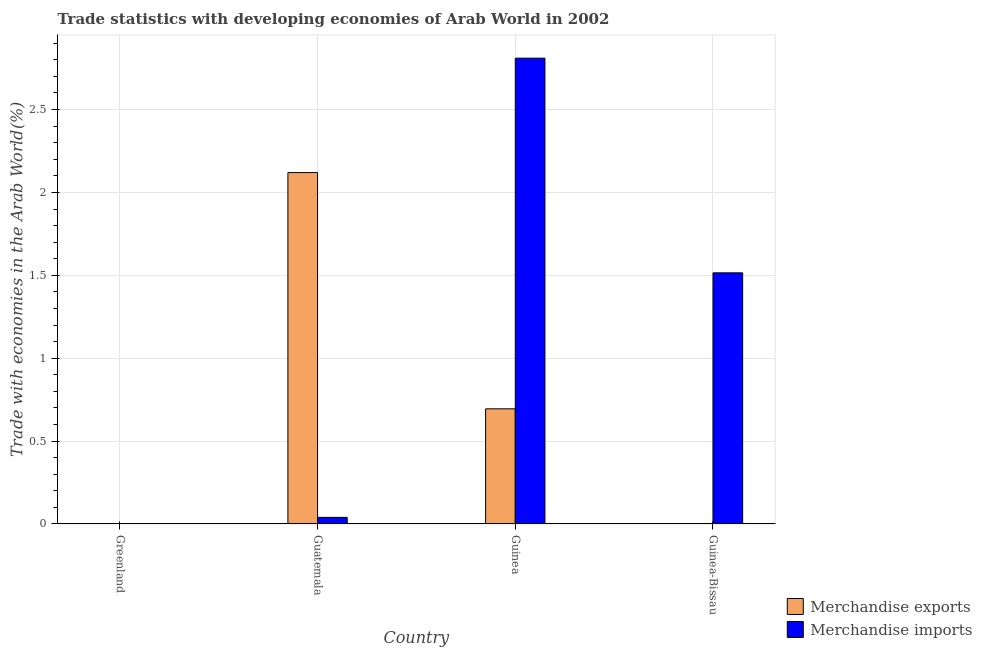How many groups of bars are there?
Offer a terse response. 4. Are the number of bars per tick equal to the number of legend labels?
Provide a short and direct response. Yes. What is the label of the 3rd group of bars from the left?
Provide a short and direct response. Guinea. What is the merchandise exports in Greenland?
Give a very brief answer. 0. Across all countries, what is the maximum merchandise exports?
Keep it short and to the point. 2.12. Across all countries, what is the minimum merchandise exports?
Provide a short and direct response. 0. In which country was the merchandise imports maximum?
Your answer should be very brief. Guinea. In which country was the merchandise exports minimum?
Your response must be concise. Greenland. What is the total merchandise exports in the graph?
Your response must be concise. 2.82. What is the difference between the merchandise imports in Guatemala and that in Guinea-Bissau?
Provide a succinct answer. -1.48. What is the difference between the merchandise exports in Greenland and the merchandise imports in Guinea?
Provide a short and direct response. -2.81. What is the average merchandise exports per country?
Provide a short and direct response. 0.7. What is the difference between the merchandise imports and merchandise exports in Guatemala?
Provide a short and direct response. -2.08. What is the ratio of the merchandise exports in Greenland to that in Guatemala?
Your answer should be compact. 8.268428974490069e-5. What is the difference between the highest and the second highest merchandise imports?
Make the answer very short. 1.29. What is the difference between the highest and the lowest merchandise imports?
Provide a succinct answer. 2.81. In how many countries, is the merchandise exports greater than the average merchandise exports taken over all countries?
Provide a short and direct response. 1. Is the sum of the merchandise imports in Greenland and Guinea-Bissau greater than the maximum merchandise exports across all countries?
Offer a very short reply. No. How many bars are there?
Your response must be concise. 8. Are all the bars in the graph horizontal?
Make the answer very short. No. How many countries are there in the graph?
Offer a terse response. 4. How many legend labels are there?
Your answer should be compact. 2. What is the title of the graph?
Offer a terse response. Trade statistics with developing economies of Arab World in 2002. What is the label or title of the Y-axis?
Your answer should be compact. Trade with economies in the Arab World(%). What is the Trade with economies in the Arab World(%) of Merchandise exports in Greenland?
Provide a short and direct response. 0. What is the Trade with economies in the Arab World(%) of Merchandise imports in Greenland?
Your answer should be very brief. 0. What is the Trade with economies in the Arab World(%) of Merchandise exports in Guatemala?
Provide a short and direct response. 2.12. What is the Trade with economies in the Arab World(%) of Merchandise imports in Guatemala?
Offer a terse response. 0.04. What is the Trade with economies in the Arab World(%) in Merchandise exports in Guinea?
Your response must be concise. 0.69. What is the Trade with economies in the Arab World(%) of Merchandise imports in Guinea?
Ensure brevity in your answer.  2.81. What is the Trade with economies in the Arab World(%) of Merchandise exports in Guinea-Bissau?
Your response must be concise. 0. What is the Trade with economies in the Arab World(%) in Merchandise imports in Guinea-Bissau?
Provide a short and direct response. 1.52. Across all countries, what is the maximum Trade with economies in the Arab World(%) in Merchandise exports?
Keep it short and to the point. 2.12. Across all countries, what is the maximum Trade with economies in the Arab World(%) in Merchandise imports?
Offer a very short reply. 2.81. Across all countries, what is the minimum Trade with economies in the Arab World(%) of Merchandise exports?
Keep it short and to the point. 0. Across all countries, what is the minimum Trade with economies in the Arab World(%) of Merchandise imports?
Your answer should be very brief. 0. What is the total Trade with economies in the Arab World(%) of Merchandise exports in the graph?
Ensure brevity in your answer.  2.82. What is the total Trade with economies in the Arab World(%) of Merchandise imports in the graph?
Ensure brevity in your answer.  4.37. What is the difference between the Trade with economies in the Arab World(%) of Merchandise exports in Greenland and that in Guatemala?
Your answer should be very brief. -2.12. What is the difference between the Trade with economies in the Arab World(%) of Merchandise imports in Greenland and that in Guatemala?
Keep it short and to the point. -0.04. What is the difference between the Trade with economies in the Arab World(%) of Merchandise exports in Greenland and that in Guinea?
Offer a terse response. -0.69. What is the difference between the Trade with economies in the Arab World(%) of Merchandise imports in Greenland and that in Guinea?
Keep it short and to the point. -2.81. What is the difference between the Trade with economies in the Arab World(%) of Merchandise exports in Greenland and that in Guinea-Bissau?
Provide a succinct answer. -0. What is the difference between the Trade with economies in the Arab World(%) of Merchandise imports in Greenland and that in Guinea-Bissau?
Make the answer very short. -1.51. What is the difference between the Trade with economies in the Arab World(%) of Merchandise exports in Guatemala and that in Guinea?
Your answer should be compact. 1.43. What is the difference between the Trade with economies in the Arab World(%) of Merchandise imports in Guatemala and that in Guinea?
Ensure brevity in your answer.  -2.77. What is the difference between the Trade with economies in the Arab World(%) in Merchandise exports in Guatemala and that in Guinea-Bissau?
Provide a short and direct response. 2.12. What is the difference between the Trade with economies in the Arab World(%) of Merchandise imports in Guatemala and that in Guinea-Bissau?
Ensure brevity in your answer.  -1.48. What is the difference between the Trade with economies in the Arab World(%) in Merchandise exports in Guinea and that in Guinea-Bissau?
Give a very brief answer. 0.69. What is the difference between the Trade with economies in the Arab World(%) in Merchandise imports in Guinea and that in Guinea-Bissau?
Your answer should be compact. 1.29. What is the difference between the Trade with economies in the Arab World(%) in Merchandise exports in Greenland and the Trade with economies in the Arab World(%) in Merchandise imports in Guatemala?
Ensure brevity in your answer.  -0.04. What is the difference between the Trade with economies in the Arab World(%) of Merchandise exports in Greenland and the Trade with economies in the Arab World(%) of Merchandise imports in Guinea?
Make the answer very short. -2.81. What is the difference between the Trade with economies in the Arab World(%) in Merchandise exports in Greenland and the Trade with economies in the Arab World(%) in Merchandise imports in Guinea-Bissau?
Provide a short and direct response. -1.51. What is the difference between the Trade with economies in the Arab World(%) of Merchandise exports in Guatemala and the Trade with economies in the Arab World(%) of Merchandise imports in Guinea?
Make the answer very short. -0.69. What is the difference between the Trade with economies in the Arab World(%) in Merchandise exports in Guatemala and the Trade with economies in the Arab World(%) in Merchandise imports in Guinea-Bissau?
Your answer should be compact. 0.6. What is the difference between the Trade with economies in the Arab World(%) of Merchandise exports in Guinea and the Trade with economies in the Arab World(%) of Merchandise imports in Guinea-Bissau?
Offer a very short reply. -0.82. What is the average Trade with economies in the Arab World(%) of Merchandise exports per country?
Provide a succinct answer. 0.7. What is the average Trade with economies in the Arab World(%) of Merchandise imports per country?
Ensure brevity in your answer.  1.09. What is the difference between the Trade with economies in the Arab World(%) of Merchandise exports and Trade with economies in the Arab World(%) of Merchandise imports in Greenland?
Offer a very short reply. -0. What is the difference between the Trade with economies in the Arab World(%) in Merchandise exports and Trade with economies in the Arab World(%) in Merchandise imports in Guatemala?
Provide a succinct answer. 2.08. What is the difference between the Trade with economies in the Arab World(%) of Merchandise exports and Trade with economies in the Arab World(%) of Merchandise imports in Guinea?
Make the answer very short. -2.12. What is the difference between the Trade with economies in the Arab World(%) in Merchandise exports and Trade with economies in the Arab World(%) in Merchandise imports in Guinea-Bissau?
Your response must be concise. -1.51. What is the ratio of the Trade with economies in the Arab World(%) in Merchandise imports in Greenland to that in Guatemala?
Make the answer very short. 0.03. What is the ratio of the Trade with economies in the Arab World(%) of Merchandise exports in Greenland to that in Guinea-Bissau?
Ensure brevity in your answer.  0.12. What is the ratio of the Trade with economies in the Arab World(%) of Merchandise imports in Greenland to that in Guinea-Bissau?
Offer a terse response. 0. What is the ratio of the Trade with economies in the Arab World(%) of Merchandise exports in Guatemala to that in Guinea?
Your answer should be compact. 3.05. What is the ratio of the Trade with economies in the Arab World(%) in Merchandise imports in Guatemala to that in Guinea?
Ensure brevity in your answer.  0.01. What is the ratio of the Trade with economies in the Arab World(%) in Merchandise exports in Guatemala to that in Guinea-Bissau?
Provide a succinct answer. 1447.77. What is the ratio of the Trade with economies in the Arab World(%) of Merchandise imports in Guatemala to that in Guinea-Bissau?
Your answer should be very brief. 0.03. What is the ratio of the Trade with economies in the Arab World(%) of Merchandise exports in Guinea to that in Guinea-Bissau?
Ensure brevity in your answer.  474.43. What is the ratio of the Trade with economies in the Arab World(%) of Merchandise imports in Guinea to that in Guinea-Bissau?
Provide a short and direct response. 1.85. What is the difference between the highest and the second highest Trade with economies in the Arab World(%) of Merchandise exports?
Provide a short and direct response. 1.43. What is the difference between the highest and the second highest Trade with economies in the Arab World(%) of Merchandise imports?
Offer a terse response. 1.29. What is the difference between the highest and the lowest Trade with economies in the Arab World(%) of Merchandise exports?
Offer a very short reply. 2.12. What is the difference between the highest and the lowest Trade with economies in the Arab World(%) of Merchandise imports?
Offer a very short reply. 2.81. 